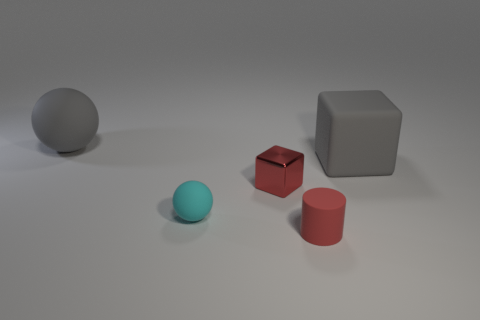Are there any big objects?
Provide a short and direct response. Yes. There is a metallic object; is it the same size as the object in front of the small cyan matte sphere?
Provide a succinct answer. Yes. There is a gray rubber object to the left of the big gray block; is there a red rubber object that is left of it?
Offer a very short reply. No. There is a tiny thing that is both in front of the tiny red metallic thing and behind the tiny red matte cylinder; what is its material?
Provide a short and direct response. Rubber. What is the color of the matte ball that is on the right side of the gray rubber thing that is to the left of the tiny rubber thing on the right side of the tiny red metallic cube?
Make the answer very short. Cyan. What is the color of the shiny object that is the same size as the red rubber object?
Give a very brief answer. Red. There is a tiny metallic object; does it have the same color as the rubber sphere behind the tiny rubber sphere?
Offer a terse response. No. There is a large thing in front of the big rubber thing to the left of the small metallic block; what is its material?
Keep it short and to the point. Rubber. What number of things are in front of the tiny matte ball and behind the small red cube?
Give a very brief answer. 0. How many other things are the same size as the gray sphere?
Offer a very short reply. 1. 